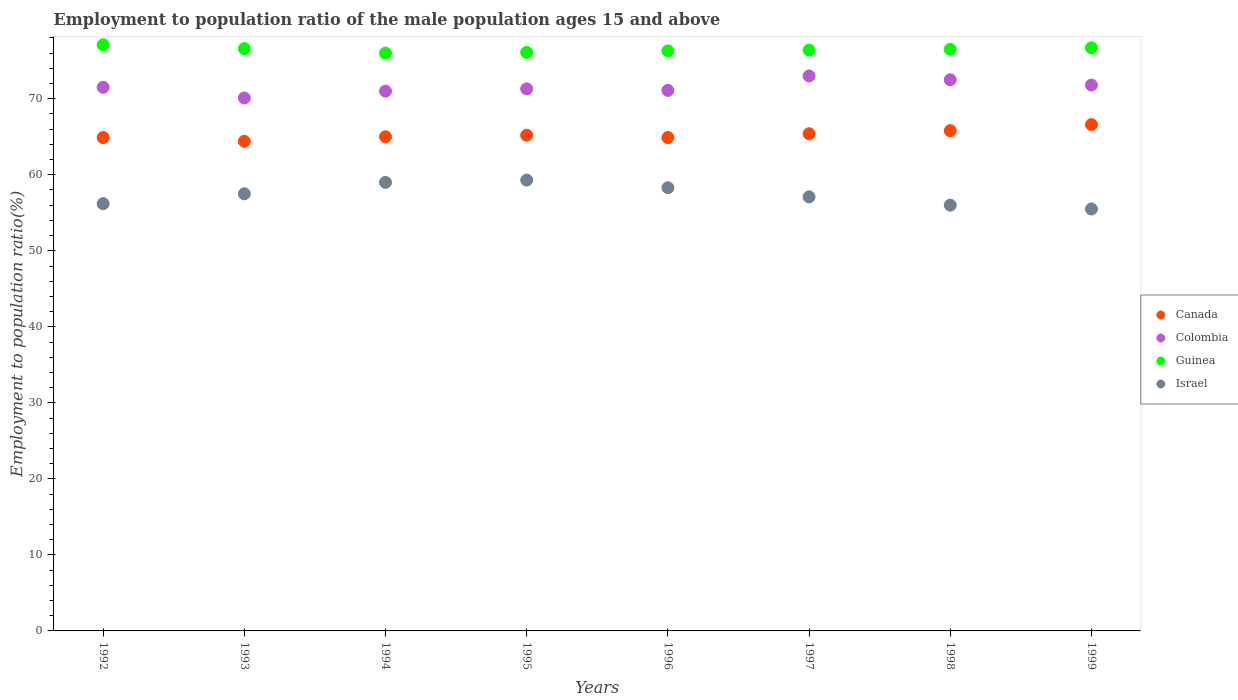Is the number of dotlines equal to the number of legend labels?
Give a very brief answer. Yes. What is the employment to population ratio in Guinea in 1992?
Ensure brevity in your answer.  77.1. Across all years, what is the minimum employment to population ratio in Canada?
Offer a very short reply. 64.4. In which year was the employment to population ratio in Guinea maximum?
Provide a short and direct response. 1992. What is the total employment to population ratio in Israel in the graph?
Your answer should be compact. 458.9. What is the difference between the employment to population ratio in Guinea in 1995 and that in 1999?
Offer a very short reply. -0.6. What is the difference between the employment to population ratio in Colombia in 1992 and the employment to population ratio in Canada in 1997?
Ensure brevity in your answer.  6.1. What is the average employment to population ratio in Guinea per year?
Give a very brief answer. 76.46. In the year 1993, what is the difference between the employment to population ratio in Canada and employment to population ratio in Colombia?
Offer a terse response. -5.7. In how many years, is the employment to population ratio in Guinea greater than 14 %?
Make the answer very short. 8. What is the ratio of the employment to population ratio in Guinea in 1993 to that in 1996?
Offer a terse response. 1. What is the difference between the highest and the lowest employment to population ratio in Guinea?
Offer a very short reply. 1.1. In how many years, is the employment to population ratio in Guinea greater than the average employment to population ratio in Guinea taken over all years?
Ensure brevity in your answer.  4. Does the employment to population ratio in Israel monotonically increase over the years?
Provide a succinct answer. No. Is the employment to population ratio in Israel strictly less than the employment to population ratio in Canada over the years?
Keep it short and to the point. Yes. How many dotlines are there?
Your answer should be very brief. 4. What is the difference between two consecutive major ticks on the Y-axis?
Offer a very short reply. 10. Does the graph contain any zero values?
Ensure brevity in your answer.  No. What is the title of the graph?
Offer a terse response. Employment to population ratio of the male population ages 15 and above. What is the label or title of the Y-axis?
Keep it short and to the point. Employment to population ratio(%). What is the Employment to population ratio(%) in Canada in 1992?
Offer a very short reply. 64.9. What is the Employment to population ratio(%) of Colombia in 1992?
Provide a succinct answer. 71.5. What is the Employment to population ratio(%) in Guinea in 1992?
Give a very brief answer. 77.1. What is the Employment to population ratio(%) of Israel in 1992?
Ensure brevity in your answer.  56.2. What is the Employment to population ratio(%) of Canada in 1993?
Your answer should be compact. 64.4. What is the Employment to population ratio(%) in Colombia in 1993?
Give a very brief answer. 70.1. What is the Employment to population ratio(%) of Guinea in 1993?
Offer a very short reply. 76.6. What is the Employment to population ratio(%) in Israel in 1993?
Your response must be concise. 57.5. What is the Employment to population ratio(%) of Guinea in 1994?
Offer a terse response. 76. What is the Employment to population ratio(%) in Israel in 1994?
Give a very brief answer. 59. What is the Employment to population ratio(%) of Canada in 1995?
Keep it short and to the point. 65.2. What is the Employment to population ratio(%) of Colombia in 1995?
Make the answer very short. 71.3. What is the Employment to population ratio(%) in Guinea in 1995?
Provide a succinct answer. 76.1. What is the Employment to population ratio(%) in Israel in 1995?
Make the answer very short. 59.3. What is the Employment to population ratio(%) in Canada in 1996?
Make the answer very short. 64.9. What is the Employment to population ratio(%) in Colombia in 1996?
Your response must be concise. 71.1. What is the Employment to population ratio(%) in Guinea in 1996?
Your response must be concise. 76.3. What is the Employment to population ratio(%) of Israel in 1996?
Ensure brevity in your answer.  58.3. What is the Employment to population ratio(%) in Canada in 1997?
Make the answer very short. 65.4. What is the Employment to population ratio(%) in Colombia in 1997?
Keep it short and to the point. 73. What is the Employment to population ratio(%) in Guinea in 1997?
Offer a very short reply. 76.4. What is the Employment to population ratio(%) in Israel in 1997?
Provide a succinct answer. 57.1. What is the Employment to population ratio(%) in Canada in 1998?
Keep it short and to the point. 65.8. What is the Employment to population ratio(%) of Colombia in 1998?
Provide a short and direct response. 72.5. What is the Employment to population ratio(%) in Guinea in 1998?
Provide a succinct answer. 76.5. What is the Employment to population ratio(%) in Canada in 1999?
Keep it short and to the point. 66.6. What is the Employment to population ratio(%) of Colombia in 1999?
Offer a terse response. 71.8. What is the Employment to population ratio(%) of Guinea in 1999?
Offer a very short reply. 76.7. What is the Employment to population ratio(%) of Israel in 1999?
Offer a terse response. 55.5. Across all years, what is the maximum Employment to population ratio(%) in Canada?
Ensure brevity in your answer.  66.6. Across all years, what is the maximum Employment to population ratio(%) in Guinea?
Provide a short and direct response. 77.1. Across all years, what is the maximum Employment to population ratio(%) in Israel?
Ensure brevity in your answer.  59.3. Across all years, what is the minimum Employment to population ratio(%) of Canada?
Your answer should be very brief. 64.4. Across all years, what is the minimum Employment to population ratio(%) of Colombia?
Your response must be concise. 70.1. Across all years, what is the minimum Employment to population ratio(%) in Israel?
Ensure brevity in your answer.  55.5. What is the total Employment to population ratio(%) in Canada in the graph?
Your response must be concise. 522.2. What is the total Employment to population ratio(%) of Colombia in the graph?
Offer a very short reply. 572.3. What is the total Employment to population ratio(%) in Guinea in the graph?
Ensure brevity in your answer.  611.7. What is the total Employment to population ratio(%) of Israel in the graph?
Your answer should be very brief. 458.9. What is the difference between the Employment to population ratio(%) of Canada in 1992 and that in 1993?
Give a very brief answer. 0.5. What is the difference between the Employment to population ratio(%) in Colombia in 1992 and that in 1993?
Your response must be concise. 1.4. What is the difference between the Employment to population ratio(%) in Guinea in 1992 and that in 1995?
Provide a short and direct response. 1. What is the difference between the Employment to population ratio(%) in Israel in 1992 and that in 1995?
Provide a short and direct response. -3.1. What is the difference between the Employment to population ratio(%) of Canada in 1992 and that in 1996?
Give a very brief answer. 0. What is the difference between the Employment to population ratio(%) of Colombia in 1992 and that in 1996?
Provide a short and direct response. 0.4. What is the difference between the Employment to population ratio(%) of Israel in 1992 and that in 1996?
Your answer should be very brief. -2.1. What is the difference between the Employment to population ratio(%) in Canada in 1992 and that in 1997?
Keep it short and to the point. -0.5. What is the difference between the Employment to population ratio(%) in Guinea in 1992 and that in 1997?
Provide a short and direct response. 0.7. What is the difference between the Employment to population ratio(%) of Israel in 1992 and that in 1997?
Make the answer very short. -0.9. What is the difference between the Employment to population ratio(%) of Canada in 1992 and that in 1998?
Keep it short and to the point. -0.9. What is the difference between the Employment to population ratio(%) in Israel in 1992 and that in 1998?
Your answer should be very brief. 0.2. What is the difference between the Employment to population ratio(%) of Guinea in 1992 and that in 1999?
Give a very brief answer. 0.4. What is the difference between the Employment to population ratio(%) of Israel in 1992 and that in 1999?
Provide a succinct answer. 0.7. What is the difference between the Employment to population ratio(%) of Colombia in 1993 and that in 1994?
Provide a succinct answer. -0.9. What is the difference between the Employment to population ratio(%) in Guinea in 1993 and that in 1994?
Ensure brevity in your answer.  0.6. What is the difference between the Employment to population ratio(%) of Colombia in 1993 and that in 1995?
Your response must be concise. -1.2. What is the difference between the Employment to population ratio(%) of Guinea in 1993 and that in 1996?
Ensure brevity in your answer.  0.3. What is the difference between the Employment to population ratio(%) of Israel in 1993 and that in 1997?
Make the answer very short. 0.4. What is the difference between the Employment to population ratio(%) of Canada in 1993 and that in 1998?
Your answer should be very brief. -1.4. What is the difference between the Employment to population ratio(%) in Guinea in 1993 and that in 1998?
Offer a terse response. 0.1. What is the difference between the Employment to population ratio(%) of Colombia in 1993 and that in 1999?
Your answer should be very brief. -1.7. What is the difference between the Employment to population ratio(%) in Guinea in 1993 and that in 1999?
Give a very brief answer. -0.1. What is the difference between the Employment to population ratio(%) of Israel in 1993 and that in 1999?
Provide a short and direct response. 2. What is the difference between the Employment to population ratio(%) of Israel in 1994 and that in 1995?
Provide a short and direct response. -0.3. What is the difference between the Employment to population ratio(%) of Canada in 1994 and that in 1996?
Provide a succinct answer. 0.1. What is the difference between the Employment to population ratio(%) in Guinea in 1994 and that in 1996?
Your answer should be compact. -0.3. What is the difference between the Employment to population ratio(%) of Canada in 1994 and that in 1997?
Your answer should be compact. -0.4. What is the difference between the Employment to population ratio(%) of Israel in 1994 and that in 1997?
Provide a succinct answer. 1.9. What is the difference between the Employment to population ratio(%) of Canada in 1994 and that in 1998?
Your answer should be compact. -0.8. What is the difference between the Employment to population ratio(%) in Israel in 1994 and that in 1998?
Your answer should be very brief. 3. What is the difference between the Employment to population ratio(%) of Colombia in 1994 and that in 1999?
Offer a very short reply. -0.8. What is the difference between the Employment to population ratio(%) of Canada in 1995 and that in 1996?
Give a very brief answer. 0.3. What is the difference between the Employment to population ratio(%) in Colombia in 1995 and that in 1996?
Keep it short and to the point. 0.2. What is the difference between the Employment to population ratio(%) in Guinea in 1995 and that in 1996?
Keep it short and to the point. -0.2. What is the difference between the Employment to population ratio(%) of Israel in 1995 and that in 1996?
Give a very brief answer. 1. What is the difference between the Employment to population ratio(%) in Canada in 1995 and that in 1997?
Your answer should be very brief. -0.2. What is the difference between the Employment to population ratio(%) of Colombia in 1995 and that in 1997?
Provide a short and direct response. -1.7. What is the difference between the Employment to population ratio(%) of Guinea in 1995 and that in 1997?
Your answer should be very brief. -0.3. What is the difference between the Employment to population ratio(%) of Colombia in 1995 and that in 1998?
Offer a very short reply. -1.2. What is the difference between the Employment to population ratio(%) of Canada in 1995 and that in 1999?
Provide a succinct answer. -1.4. What is the difference between the Employment to population ratio(%) of Israel in 1995 and that in 1999?
Your answer should be very brief. 3.8. What is the difference between the Employment to population ratio(%) in Colombia in 1996 and that in 1998?
Offer a terse response. -1.4. What is the difference between the Employment to population ratio(%) in Israel in 1996 and that in 1998?
Offer a very short reply. 2.3. What is the difference between the Employment to population ratio(%) in Canada in 1996 and that in 1999?
Make the answer very short. -1.7. What is the difference between the Employment to population ratio(%) in Israel in 1996 and that in 1999?
Your response must be concise. 2.8. What is the difference between the Employment to population ratio(%) in Canada in 1997 and that in 1998?
Your answer should be compact. -0.4. What is the difference between the Employment to population ratio(%) in Israel in 1997 and that in 1998?
Provide a succinct answer. 1.1. What is the difference between the Employment to population ratio(%) of Guinea in 1997 and that in 1999?
Your response must be concise. -0.3. What is the difference between the Employment to population ratio(%) in Canada in 1998 and that in 1999?
Your answer should be compact. -0.8. What is the difference between the Employment to population ratio(%) of Guinea in 1998 and that in 1999?
Your answer should be very brief. -0.2. What is the difference between the Employment to population ratio(%) of Israel in 1998 and that in 1999?
Offer a very short reply. 0.5. What is the difference between the Employment to population ratio(%) in Canada in 1992 and the Employment to population ratio(%) in Colombia in 1993?
Offer a very short reply. -5.2. What is the difference between the Employment to population ratio(%) of Canada in 1992 and the Employment to population ratio(%) of Guinea in 1993?
Your response must be concise. -11.7. What is the difference between the Employment to population ratio(%) in Canada in 1992 and the Employment to population ratio(%) in Israel in 1993?
Give a very brief answer. 7.4. What is the difference between the Employment to population ratio(%) in Colombia in 1992 and the Employment to population ratio(%) in Guinea in 1993?
Provide a succinct answer. -5.1. What is the difference between the Employment to population ratio(%) in Colombia in 1992 and the Employment to population ratio(%) in Israel in 1993?
Provide a short and direct response. 14. What is the difference between the Employment to population ratio(%) in Guinea in 1992 and the Employment to population ratio(%) in Israel in 1993?
Make the answer very short. 19.6. What is the difference between the Employment to population ratio(%) of Colombia in 1992 and the Employment to population ratio(%) of Guinea in 1994?
Offer a very short reply. -4.5. What is the difference between the Employment to population ratio(%) of Colombia in 1992 and the Employment to population ratio(%) of Israel in 1994?
Offer a terse response. 12.5. What is the difference between the Employment to population ratio(%) in Canada in 1992 and the Employment to population ratio(%) in Colombia in 1995?
Keep it short and to the point. -6.4. What is the difference between the Employment to population ratio(%) in Canada in 1992 and the Employment to population ratio(%) in Guinea in 1995?
Provide a short and direct response. -11.2. What is the difference between the Employment to population ratio(%) of Canada in 1992 and the Employment to population ratio(%) of Israel in 1995?
Keep it short and to the point. 5.6. What is the difference between the Employment to population ratio(%) of Canada in 1992 and the Employment to population ratio(%) of Israel in 1996?
Offer a terse response. 6.6. What is the difference between the Employment to population ratio(%) in Colombia in 1992 and the Employment to population ratio(%) in Guinea in 1996?
Give a very brief answer. -4.8. What is the difference between the Employment to population ratio(%) in Canada in 1992 and the Employment to population ratio(%) in Guinea in 1997?
Offer a very short reply. -11.5. What is the difference between the Employment to population ratio(%) in Canada in 1992 and the Employment to population ratio(%) in Israel in 1997?
Give a very brief answer. 7.8. What is the difference between the Employment to population ratio(%) of Colombia in 1992 and the Employment to population ratio(%) of Guinea in 1997?
Offer a very short reply. -4.9. What is the difference between the Employment to population ratio(%) of Colombia in 1992 and the Employment to population ratio(%) of Israel in 1997?
Keep it short and to the point. 14.4. What is the difference between the Employment to population ratio(%) of Canada in 1992 and the Employment to population ratio(%) of Guinea in 1998?
Make the answer very short. -11.6. What is the difference between the Employment to population ratio(%) of Colombia in 1992 and the Employment to population ratio(%) of Guinea in 1998?
Offer a very short reply. -5. What is the difference between the Employment to population ratio(%) of Guinea in 1992 and the Employment to population ratio(%) of Israel in 1998?
Provide a succinct answer. 21.1. What is the difference between the Employment to population ratio(%) of Canada in 1992 and the Employment to population ratio(%) of Guinea in 1999?
Keep it short and to the point. -11.8. What is the difference between the Employment to population ratio(%) of Canada in 1992 and the Employment to population ratio(%) of Israel in 1999?
Give a very brief answer. 9.4. What is the difference between the Employment to population ratio(%) of Colombia in 1992 and the Employment to population ratio(%) of Israel in 1999?
Keep it short and to the point. 16. What is the difference between the Employment to population ratio(%) of Guinea in 1992 and the Employment to population ratio(%) of Israel in 1999?
Your answer should be very brief. 21.6. What is the difference between the Employment to population ratio(%) of Canada in 1993 and the Employment to population ratio(%) of Colombia in 1994?
Keep it short and to the point. -6.6. What is the difference between the Employment to population ratio(%) of Colombia in 1993 and the Employment to population ratio(%) of Guinea in 1994?
Provide a short and direct response. -5.9. What is the difference between the Employment to population ratio(%) of Canada in 1993 and the Employment to population ratio(%) of Colombia in 1995?
Make the answer very short. -6.9. What is the difference between the Employment to population ratio(%) of Canada in 1993 and the Employment to population ratio(%) of Guinea in 1995?
Provide a short and direct response. -11.7. What is the difference between the Employment to population ratio(%) of Canada in 1993 and the Employment to population ratio(%) of Israel in 1995?
Your answer should be compact. 5.1. What is the difference between the Employment to population ratio(%) in Colombia in 1993 and the Employment to population ratio(%) in Israel in 1995?
Ensure brevity in your answer.  10.8. What is the difference between the Employment to population ratio(%) of Canada in 1993 and the Employment to population ratio(%) of Colombia in 1996?
Your answer should be very brief. -6.7. What is the difference between the Employment to population ratio(%) of Canada in 1993 and the Employment to population ratio(%) of Israel in 1996?
Your answer should be compact. 6.1. What is the difference between the Employment to population ratio(%) in Colombia in 1993 and the Employment to population ratio(%) in Israel in 1996?
Provide a succinct answer. 11.8. What is the difference between the Employment to population ratio(%) of Canada in 1993 and the Employment to population ratio(%) of Guinea in 1997?
Keep it short and to the point. -12. What is the difference between the Employment to population ratio(%) of Canada in 1993 and the Employment to population ratio(%) of Colombia in 1998?
Your answer should be compact. -8.1. What is the difference between the Employment to population ratio(%) of Canada in 1993 and the Employment to population ratio(%) of Israel in 1998?
Make the answer very short. 8.4. What is the difference between the Employment to population ratio(%) in Colombia in 1993 and the Employment to population ratio(%) in Guinea in 1998?
Ensure brevity in your answer.  -6.4. What is the difference between the Employment to population ratio(%) in Guinea in 1993 and the Employment to population ratio(%) in Israel in 1998?
Make the answer very short. 20.6. What is the difference between the Employment to population ratio(%) in Colombia in 1993 and the Employment to population ratio(%) in Guinea in 1999?
Give a very brief answer. -6.6. What is the difference between the Employment to population ratio(%) of Colombia in 1993 and the Employment to population ratio(%) of Israel in 1999?
Your answer should be compact. 14.6. What is the difference between the Employment to population ratio(%) in Guinea in 1993 and the Employment to population ratio(%) in Israel in 1999?
Your answer should be very brief. 21.1. What is the difference between the Employment to population ratio(%) in Canada in 1994 and the Employment to population ratio(%) in Colombia in 1995?
Ensure brevity in your answer.  -6.3. What is the difference between the Employment to population ratio(%) in Canada in 1994 and the Employment to population ratio(%) in Israel in 1995?
Your answer should be very brief. 5.7. What is the difference between the Employment to population ratio(%) of Colombia in 1994 and the Employment to population ratio(%) of Israel in 1995?
Your answer should be very brief. 11.7. What is the difference between the Employment to population ratio(%) of Canada in 1994 and the Employment to population ratio(%) of Guinea in 1996?
Give a very brief answer. -11.3. What is the difference between the Employment to population ratio(%) in Canada in 1994 and the Employment to population ratio(%) in Israel in 1996?
Keep it short and to the point. 6.7. What is the difference between the Employment to population ratio(%) of Canada in 1994 and the Employment to population ratio(%) of Guinea in 1997?
Your answer should be very brief. -11.4. What is the difference between the Employment to population ratio(%) in Canada in 1994 and the Employment to population ratio(%) in Israel in 1997?
Make the answer very short. 7.9. What is the difference between the Employment to population ratio(%) of Colombia in 1994 and the Employment to population ratio(%) of Israel in 1998?
Give a very brief answer. 15. What is the difference between the Employment to population ratio(%) in Guinea in 1994 and the Employment to population ratio(%) in Israel in 1998?
Make the answer very short. 20. What is the difference between the Employment to population ratio(%) of Canada in 1994 and the Employment to population ratio(%) of Guinea in 1999?
Provide a succinct answer. -11.7. What is the difference between the Employment to population ratio(%) in Colombia in 1994 and the Employment to population ratio(%) in Israel in 1999?
Ensure brevity in your answer.  15.5. What is the difference between the Employment to population ratio(%) of Guinea in 1994 and the Employment to population ratio(%) of Israel in 1999?
Your response must be concise. 20.5. What is the difference between the Employment to population ratio(%) of Canada in 1995 and the Employment to population ratio(%) of Colombia in 1996?
Your answer should be very brief. -5.9. What is the difference between the Employment to population ratio(%) of Canada in 1995 and the Employment to population ratio(%) of Guinea in 1996?
Keep it short and to the point. -11.1. What is the difference between the Employment to population ratio(%) in Colombia in 1995 and the Employment to population ratio(%) in Guinea in 1996?
Provide a short and direct response. -5. What is the difference between the Employment to population ratio(%) of Guinea in 1995 and the Employment to population ratio(%) of Israel in 1996?
Ensure brevity in your answer.  17.8. What is the difference between the Employment to population ratio(%) of Canada in 1995 and the Employment to population ratio(%) of Israel in 1997?
Your response must be concise. 8.1. What is the difference between the Employment to population ratio(%) of Colombia in 1995 and the Employment to population ratio(%) of Guinea in 1997?
Provide a short and direct response. -5.1. What is the difference between the Employment to population ratio(%) in Colombia in 1995 and the Employment to population ratio(%) in Israel in 1997?
Make the answer very short. 14.2. What is the difference between the Employment to population ratio(%) in Canada in 1995 and the Employment to population ratio(%) in Colombia in 1998?
Ensure brevity in your answer.  -7.3. What is the difference between the Employment to population ratio(%) of Canada in 1995 and the Employment to population ratio(%) of Guinea in 1998?
Provide a succinct answer. -11.3. What is the difference between the Employment to population ratio(%) of Guinea in 1995 and the Employment to population ratio(%) of Israel in 1998?
Provide a short and direct response. 20.1. What is the difference between the Employment to population ratio(%) of Colombia in 1995 and the Employment to population ratio(%) of Guinea in 1999?
Your answer should be very brief. -5.4. What is the difference between the Employment to population ratio(%) of Colombia in 1995 and the Employment to population ratio(%) of Israel in 1999?
Offer a very short reply. 15.8. What is the difference between the Employment to population ratio(%) of Guinea in 1995 and the Employment to population ratio(%) of Israel in 1999?
Keep it short and to the point. 20.6. What is the difference between the Employment to population ratio(%) of Colombia in 1996 and the Employment to population ratio(%) of Guinea in 1997?
Give a very brief answer. -5.3. What is the difference between the Employment to population ratio(%) of Guinea in 1996 and the Employment to population ratio(%) of Israel in 1997?
Ensure brevity in your answer.  19.2. What is the difference between the Employment to population ratio(%) in Colombia in 1996 and the Employment to population ratio(%) in Israel in 1998?
Your answer should be very brief. 15.1. What is the difference between the Employment to population ratio(%) of Guinea in 1996 and the Employment to population ratio(%) of Israel in 1998?
Give a very brief answer. 20.3. What is the difference between the Employment to population ratio(%) in Canada in 1996 and the Employment to population ratio(%) in Guinea in 1999?
Offer a terse response. -11.8. What is the difference between the Employment to population ratio(%) of Canada in 1996 and the Employment to population ratio(%) of Israel in 1999?
Your answer should be compact. 9.4. What is the difference between the Employment to population ratio(%) in Guinea in 1996 and the Employment to population ratio(%) in Israel in 1999?
Give a very brief answer. 20.8. What is the difference between the Employment to population ratio(%) in Canada in 1997 and the Employment to population ratio(%) in Colombia in 1998?
Offer a very short reply. -7.1. What is the difference between the Employment to population ratio(%) in Guinea in 1997 and the Employment to population ratio(%) in Israel in 1998?
Make the answer very short. 20.4. What is the difference between the Employment to population ratio(%) in Guinea in 1997 and the Employment to population ratio(%) in Israel in 1999?
Your answer should be very brief. 20.9. What is the difference between the Employment to population ratio(%) in Canada in 1998 and the Employment to population ratio(%) in Israel in 1999?
Keep it short and to the point. 10.3. What is the difference between the Employment to population ratio(%) in Colombia in 1998 and the Employment to population ratio(%) in Guinea in 1999?
Keep it short and to the point. -4.2. What is the difference between the Employment to population ratio(%) in Guinea in 1998 and the Employment to population ratio(%) in Israel in 1999?
Your response must be concise. 21. What is the average Employment to population ratio(%) in Canada per year?
Your answer should be very brief. 65.28. What is the average Employment to population ratio(%) of Colombia per year?
Offer a terse response. 71.54. What is the average Employment to population ratio(%) in Guinea per year?
Provide a short and direct response. 76.46. What is the average Employment to population ratio(%) in Israel per year?
Provide a succinct answer. 57.36. In the year 1992, what is the difference between the Employment to population ratio(%) of Colombia and Employment to population ratio(%) of Israel?
Offer a terse response. 15.3. In the year 1992, what is the difference between the Employment to population ratio(%) in Guinea and Employment to population ratio(%) in Israel?
Provide a succinct answer. 20.9. In the year 1993, what is the difference between the Employment to population ratio(%) in Canada and Employment to population ratio(%) in Israel?
Your answer should be compact. 6.9. In the year 1993, what is the difference between the Employment to population ratio(%) of Colombia and Employment to population ratio(%) of Guinea?
Ensure brevity in your answer.  -6.5. In the year 1993, what is the difference between the Employment to population ratio(%) of Guinea and Employment to population ratio(%) of Israel?
Make the answer very short. 19.1. In the year 1994, what is the difference between the Employment to population ratio(%) of Canada and Employment to population ratio(%) of Colombia?
Your answer should be very brief. -6. In the year 1994, what is the difference between the Employment to population ratio(%) of Canada and Employment to population ratio(%) of Guinea?
Offer a very short reply. -11. In the year 1995, what is the difference between the Employment to population ratio(%) in Colombia and Employment to population ratio(%) in Guinea?
Offer a terse response. -4.8. In the year 1995, what is the difference between the Employment to population ratio(%) of Colombia and Employment to population ratio(%) of Israel?
Provide a succinct answer. 12. In the year 1995, what is the difference between the Employment to population ratio(%) of Guinea and Employment to population ratio(%) of Israel?
Your answer should be very brief. 16.8. In the year 1996, what is the difference between the Employment to population ratio(%) in Canada and Employment to population ratio(%) in Guinea?
Your answer should be compact. -11.4. In the year 1996, what is the difference between the Employment to population ratio(%) of Guinea and Employment to population ratio(%) of Israel?
Your answer should be very brief. 18. In the year 1997, what is the difference between the Employment to population ratio(%) of Canada and Employment to population ratio(%) of Guinea?
Provide a succinct answer. -11. In the year 1997, what is the difference between the Employment to population ratio(%) in Colombia and Employment to population ratio(%) in Israel?
Give a very brief answer. 15.9. In the year 1997, what is the difference between the Employment to population ratio(%) in Guinea and Employment to population ratio(%) in Israel?
Your answer should be very brief. 19.3. In the year 1998, what is the difference between the Employment to population ratio(%) in Canada and Employment to population ratio(%) in Colombia?
Give a very brief answer. -6.7. In the year 1998, what is the difference between the Employment to population ratio(%) in Canada and Employment to population ratio(%) in Guinea?
Offer a very short reply. -10.7. In the year 1998, what is the difference between the Employment to population ratio(%) in Canada and Employment to population ratio(%) in Israel?
Ensure brevity in your answer.  9.8. In the year 1998, what is the difference between the Employment to population ratio(%) in Colombia and Employment to population ratio(%) in Guinea?
Give a very brief answer. -4. In the year 1999, what is the difference between the Employment to population ratio(%) of Canada and Employment to population ratio(%) of Israel?
Provide a succinct answer. 11.1. In the year 1999, what is the difference between the Employment to population ratio(%) of Colombia and Employment to population ratio(%) of Guinea?
Your answer should be compact. -4.9. In the year 1999, what is the difference between the Employment to population ratio(%) in Colombia and Employment to population ratio(%) in Israel?
Your answer should be very brief. 16.3. In the year 1999, what is the difference between the Employment to population ratio(%) in Guinea and Employment to population ratio(%) in Israel?
Give a very brief answer. 21.2. What is the ratio of the Employment to population ratio(%) of Canada in 1992 to that in 1993?
Provide a short and direct response. 1.01. What is the ratio of the Employment to population ratio(%) in Colombia in 1992 to that in 1993?
Give a very brief answer. 1.02. What is the ratio of the Employment to population ratio(%) in Guinea in 1992 to that in 1993?
Your answer should be very brief. 1.01. What is the ratio of the Employment to population ratio(%) of Israel in 1992 to that in 1993?
Offer a very short reply. 0.98. What is the ratio of the Employment to population ratio(%) of Guinea in 1992 to that in 1994?
Your response must be concise. 1.01. What is the ratio of the Employment to population ratio(%) of Israel in 1992 to that in 1994?
Your answer should be compact. 0.95. What is the ratio of the Employment to population ratio(%) in Canada in 1992 to that in 1995?
Provide a succinct answer. 1. What is the ratio of the Employment to population ratio(%) of Colombia in 1992 to that in 1995?
Give a very brief answer. 1. What is the ratio of the Employment to population ratio(%) of Guinea in 1992 to that in 1995?
Offer a very short reply. 1.01. What is the ratio of the Employment to population ratio(%) of Israel in 1992 to that in 1995?
Your response must be concise. 0.95. What is the ratio of the Employment to population ratio(%) of Canada in 1992 to that in 1996?
Give a very brief answer. 1. What is the ratio of the Employment to population ratio(%) in Colombia in 1992 to that in 1996?
Offer a terse response. 1.01. What is the ratio of the Employment to population ratio(%) in Guinea in 1992 to that in 1996?
Your answer should be compact. 1.01. What is the ratio of the Employment to population ratio(%) of Colombia in 1992 to that in 1997?
Offer a terse response. 0.98. What is the ratio of the Employment to population ratio(%) of Guinea in 1992 to that in 1997?
Your answer should be compact. 1.01. What is the ratio of the Employment to population ratio(%) in Israel in 1992 to that in 1997?
Offer a terse response. 0.98. What is the ratio of the Employment to population ratio(%) in Canada in 1992 to that in 1998?
Provide a succinct answer. 0.99. What is the ratio of the Employment to population ratio(%) in Colombia in 1992 to that in 1998?
Your answer should be very brief. 0.99. What is the ratio of the Employment to population ratio(%) in Guinea in 1992 to that in 1998?
Ensure brevity in your answer.  1.01. What is the ratio of the Employment to population ratio(%) in Israel in 1992 to that in 1998?
Your answer should be compact. 1. What is the ratio of the Employment to population ratio(%) in Canada in 1992 to that in 1999?
Offer a terse response. 0.97. What is the ratio of the Employment to population ratio(%) of Colombia in 1992 to that in 1999?
Keep it short and to the point. 1. What is the ratio of the Employment to population ratio(%) of Guinea in 1992 to that in 1999?
Your answer should be compact. 1.01. What is the ratio of the Employment to population ratio(%) of Israel in 1992 to that in 1999?
Provide a short and direct response. 1.01. What is the ratio of the Employment to population ratio(%) in Canada in 1993 to that in 1994?
Give a very brief answer. 0.99. What is the ratio of the Employment to population ratio(%) of Colombia in 1993 to that in 1994?
Offer a very short reply. 0.99. What is the ratio of the Employment to population ratio(%) of Guinea in 1993 to that in 1994?
Provide a succinct answer. 1.01. What is the ratio of the Employment to population ratio(%) of Israel in 1993 to that in 1994?
Ensure brevity in your answer.  0.97. What is the ratio of the Employment to population ratio(%) in Colombia in 1993 to that in 1995?
Your response must be concise. 0.98. What is the ratio of the Employment to population ratio(%) of Guinea in 1993 to that in 1995?
Offer a terse response. 1.01. What is the ratio of the Employment to population ratio(%) of Israel in 1993 to that in 1995?
Your response must be concise. 0.97. What is the ratio of the Employment to population ratio(%) in Colombia in 1993 to that in 1996?
Your answer should be very brief. 0.99. What is the ratio of the Employment to population ratio(%) in Israel in 1993 to that in 1996?
Ensure brevity in your answer.  0.99. What is the ratio of the Employment to population ratio(%) of Canada in 1993 to that in 1997?
Ensure brevity in your answer.  0.98. What is the ratio of the Employment to population ratio(%) in Colombia in 1993 to that in 1997?
Your answer should be compact. 0.96. What is the ratio of the Employment to population ratio(%) of Israel in 1993 to that in 1997?
Offer a very short reply. 1.01. What is the ratio of the Employment to population ratio(%) in Canada in 1993 to that in 1998?
Offer a very short reply. 0.98. What is the ratio of the Employment to population ratio(%) of Colombia in 1993 to that in 1998?
Ensure brevity in your answer.  0.97. What is the ratio of the Employment to population ratio(%) of Israel in 1993 to that in 1998?
Offer a very short reply. 1.03. What is the ratio of the Employment to population ratio(%) in Colombia in 1993 to that in 1999?
Keep it short and to the point. 0.98. What is the ratio of the Employment to population ratio(%) in Guinea in 1993 to that in 1999?
Offer a terse response. 1. What is the ratio of the Employment to population ratio(%) of Israel in 1993 to that in 1999?
Your response must be concise. 1.04. What is the ratio of the Employment to population ratio(%) in Canada in 1994 to that in 1995?
Keep it short and to the point. 1. What is the ratio of the Employment to population ratio(%) in Guinea in 1994 to that in 1995?
Ensure brevity in your answer.  1. What is the ratio of the Employment to population ratio(%) in Canada in 1994 to that in 1996?
Your response must be concise. 1. What is the ratio of the Employment to population ratio(%) of Guinea in 1994 to that in 1996?
Offer a very short reply. 1. What is the ratio of the Employment to population ratio(%) of Israel in 1994 to that in 1996?
Provide a succinct answer. 1.01. What is the ratio of the Employment to population ratio(%) in Canada in 1994 to that in 1997?
Provide a short and direct response. 0.99. What is the ratio of the Employment to population ratio(%) in Colombia in 1994 to that in 1997?
Offer a terse response. 0.97. What is the ratio of the Employment to population ratio(%) in Guinea in 1994 to that in 1997?
Your response must be concise. 0.99. What is the ratio of the Employment to population ratio(%) in Israel in 1994 to that in 1997?
Provide a succinct answer. 1.03. What is the ratio of the Employment to population ratio(%) of Colombia in 1994 to that in 1998?
Your response must be concise. 0.98. What is the ratio of the Employment to population ratio(%) of Israel in 1994 to that in 1998?
Keep it short and to the point. 1.05. What is the ratio of the Employment to population ratio(%) in Colombia in 1994 to that in 1999?
Your answer should be very brief. 0.99. What is the ratio of the Employment to population ratio(%) of Guinea in 1994 to that in 1999?
Ensure brevity in your answer.  0.99. What is the ratio of the Employment to population ratio(%) of Israel in 1994 to that in 1999?
Keep it short and to the point. 1.06. What is the ratio of the Employment to population ratio(%) in Guinea in 1995 to that in 1996?
Provide a short and direct response. 1. What is the ratio of the Employment to population ratio(%) in Israel in 1995 to that in 1996?
Provide a short and direct response. 1.02. What is the ratio of the Employment to population ratio(%) of Colombia in 1995 to that in 1997?
Keep it short and to the point. 0.98. What is the ratio of the Employment to population ratio(%) in Guinea in 1995 to that in 1997?
Offer a very short reply. 1. What is the ratio of the Employment to population ratio(%) of Israel in 1995 to that in 1997?
Your answer should be compact. 1.04. What is the ratio of the Employment to population ratio(%) in Canada in 1995 to that in 1998?
Provide a succinct answer. 0.99. What is the ratio of the Employment to population ratio(%) of Colombia in 1995 to that in 1998?
Ensure brevity in your answer.  0.98. What is the ratio of the Employment to population ratio(%) of Guinea in 1995 to that in 1998?
Your response must be concise. 0.99. What is the ratio of the Employment to population ratio(%) of Israel in 1995 to that in 1998?
Your answer should be compact. 1.06. What is the ratio of the Employment to population ratio(%) of Colombia in 1995 to that in 1999?
Your answer should be very brief. 0.99. What is the ratio of the Employment to population ratio(%) of Guinea in 1995 to that in 1999?
Ensure brevity in your answer.  0.99. What is the ratio of the Employment to population ratio(%) of Israel in 1995 to that in 1999?
Your answer should be compact. 1.07. What is the ratio of the Employment to population ratio(%) of Canada in 1996 to that in 1997?
Provide a short and direct response. 0.99. What is the ratio of the Employment to population ratio(%) of Guinea in 1996 to that in 1997?
Give a very brief answer. 1. What is the ratio of the Employment to population ratio(%) in Israel in 1996 to that in 1997?
Ensure brevity in your answer.  1.02. What is the ratio of the Employment to population ratio(%) of Canada in 1996 to that in 1998?
Your answer should be very brief. 0.99. What is the ratio of the Employment to population ratio(%) of Colombia in 1996 to that in 1998?
Ensure brevity in your answer.  0.98. What is the ratio of the Employment to population ratio(%) of Israel in 1996 to that in 1998?
Provide a short and direct response. 1.04. What is the ratio of the Employment to population ratio(%) in Canada in 1996 to that in 1999?
Provide a short and direct response. 0.97. What is the ratio of the Employment to population ratio(%) in Colombia in 1996 to that in 1999?
Give a very brief answer. 0.99. What is the ratio of the Employment to population ratio(%) of Israel in 1996 to that in 1999?
Offer a very short reply. 1.05. What is the ratio of the Employment to population ratio(%) of Canada in 1997 to that in 1998?
Give a very brief answer. 0.99. What is the ratio of the Employment to population ratio(%) in Israel in 1997 to that in 1998?
Make the answer very short. 1.02. What is the ratio of the Employment to population ratio(%) of Colombia in 1997 to that in 1999?
Your answer should be very brief. 1.02. What is the ratio of the Employment to population ratio(%) of Guinea in 1997 to that in 1999?
Ensure brevity in your answer.  1. What is the ratio of the Employment to population ratio(%) of Israel in 1997 to that in 1999?
Make the answer very short. 1.03. What is the ratio of the Employment to population ratio(%) in Canada in 1998 to that in 1999?
Ensure brevity in your answer.  0.99. What is the ratio of the Employment to population ratio(%) of Colombia in 1998 to that in 1999?
Your answer should be compact. 1.01. What is the ratio of the Employment to population ratio(%) in Guinea in 1998 to that in 1999?
Your response must be concise. 1. What is the difference between the highest and the second highest Employment to population ratio(%) in Guinea?
Keep it short and to the point. 0.4. What is the difference between the highest and the second highest Employment to population ratio(%) of Israel?
Make the answer very short. 0.3. What is the difference between the highest and the lowest Employment to population ratio(%) of Canada?
Provide a succinct answer. 2.2. What is the difference between the highest and the lowest Employment to population ratio(%) in Colombia?
Ensure brevity in your answer.  2.9. What is the difference between the highest and the lowest Employment to population ratio(%) in Guinea?
Your answer should be very brief. 1.1. What is the difference between the highest and the lowest Employment to population ratio(%) of Israel?
Provide a short and direct response. 3.8. 